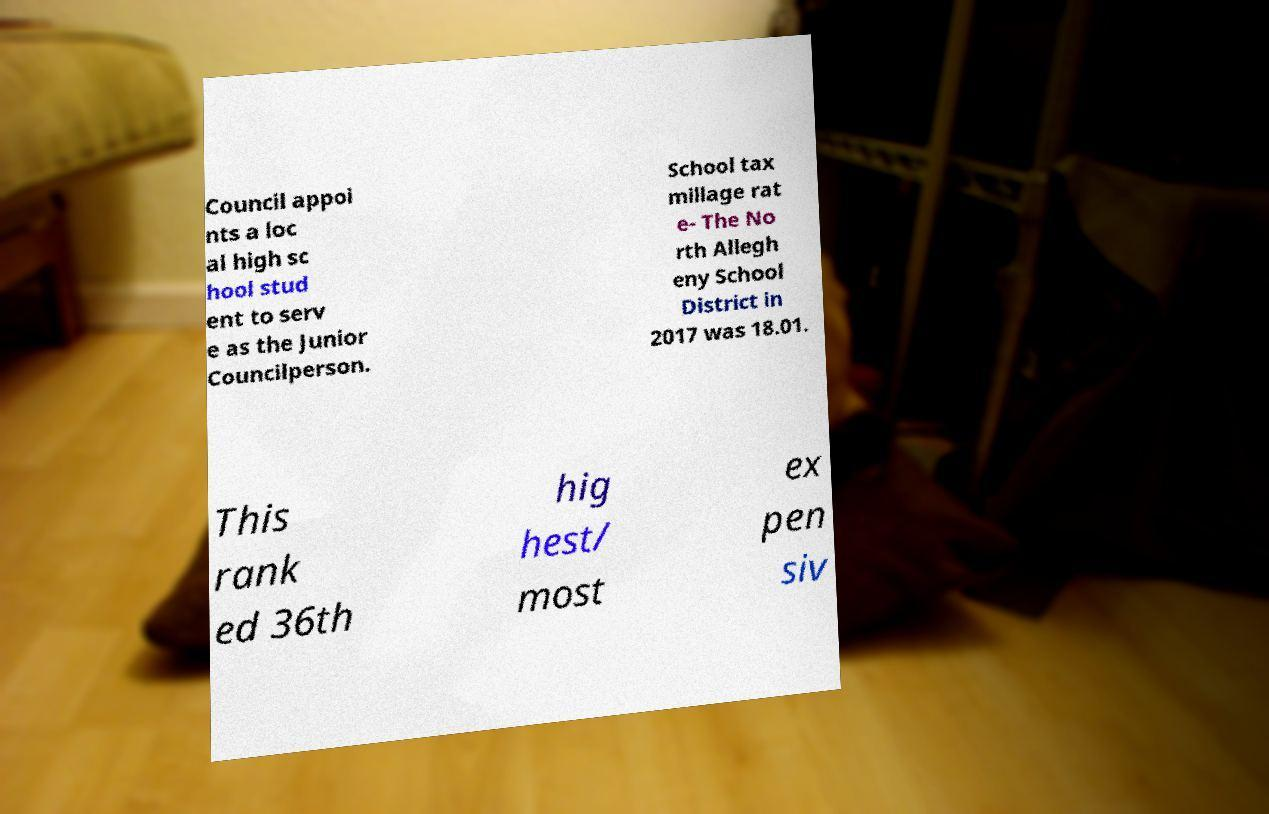Could you assist in decoding the text presented in this image and type it out clearly? Council appoi nts a loc al high sc hool stud ent to serv e as the Junior Councilperson. School tax millage rat e- The No rth Allegh eny School District in 2017 was 18.01. This rank ed 36th hig hest/ most ex pen siv 